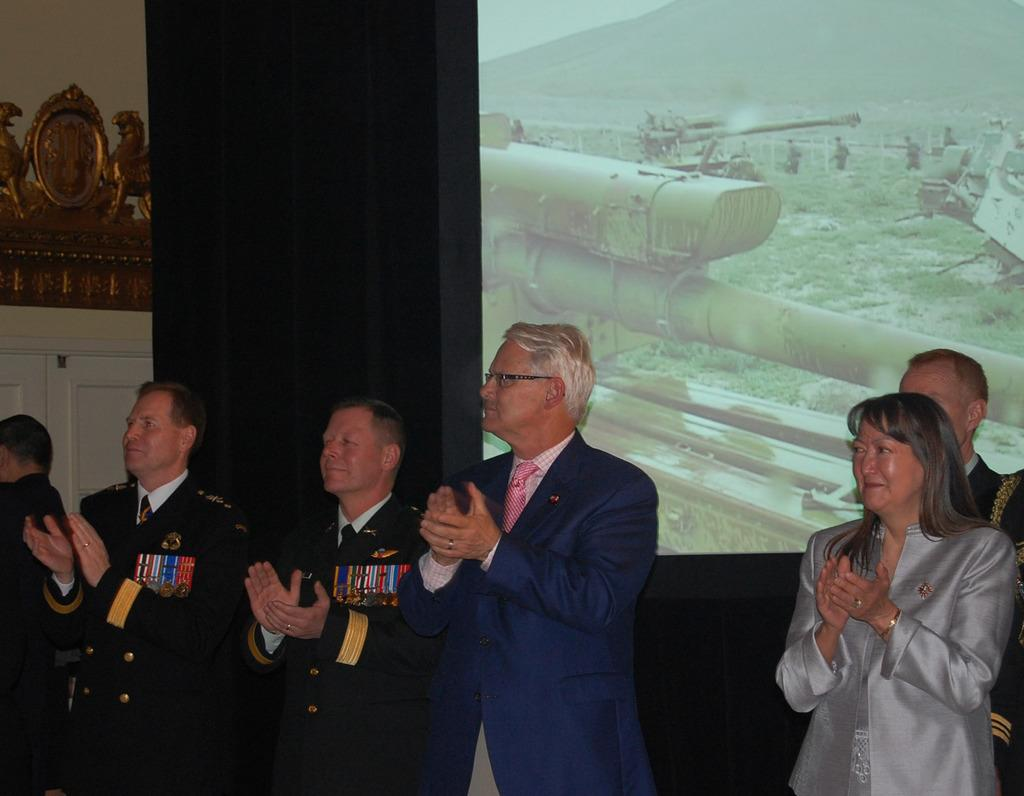What is happening in the image involving a group of people? There is a group of people standing in the image. What can be seen on the backside of the group? There is a display screen and a decoration on a wall on the backside of the group. Is there any architectural feature visible on the backside of the group? Yes, there is a door visible on the backside of the group. How many pies are being served by the women in the image? There are no women or pies present in the image. 